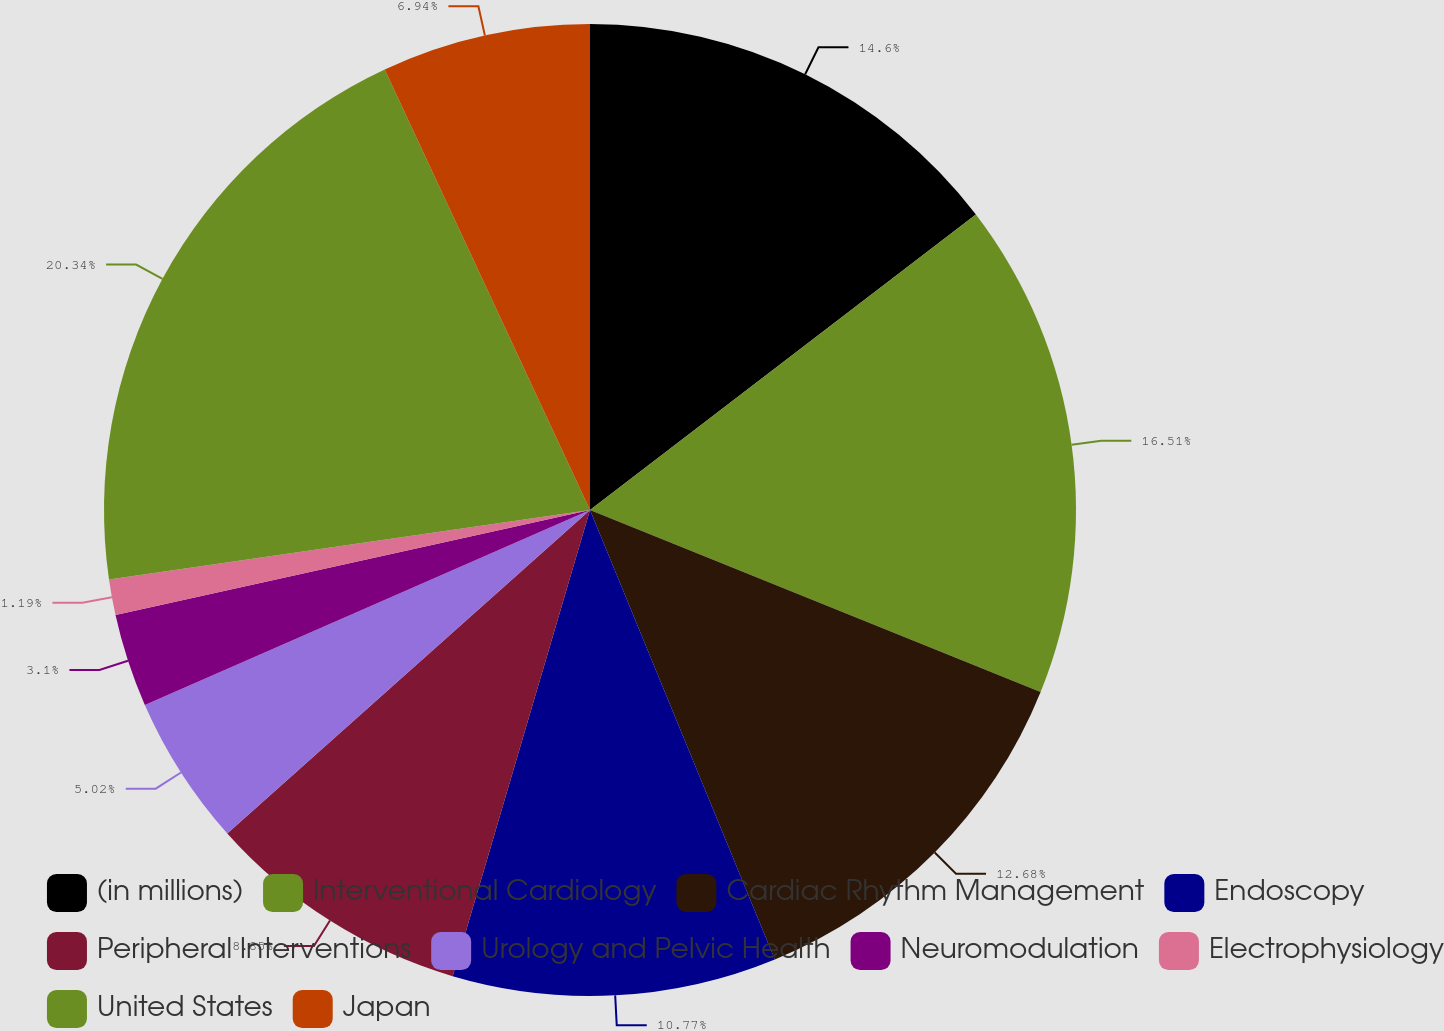Convert chart to OTSL. <chart><loc_0><loc_0><loc_500><loc_500><pie_chart><fcel>(in millions)<fcel>Interventional Cardiology<fcel>Cardiac Rhythm Management<fcel>Endoscopy<fcel>Peripheral Interventions<fcel>Urology and Pelvic Health<fcel>Neuromodulation<fcel>Electrophysiology<fcel>United States<fcel>Japan<nl><fcel>14.6%<fcel>16.51%<fcel>12.68%<fcel>10.77%<fcel>8.85%<fcel>5.02%<fcel>3.1%<fcel>1.19%<fcel>20.34%<fcel>6.94%<nl></chart> 